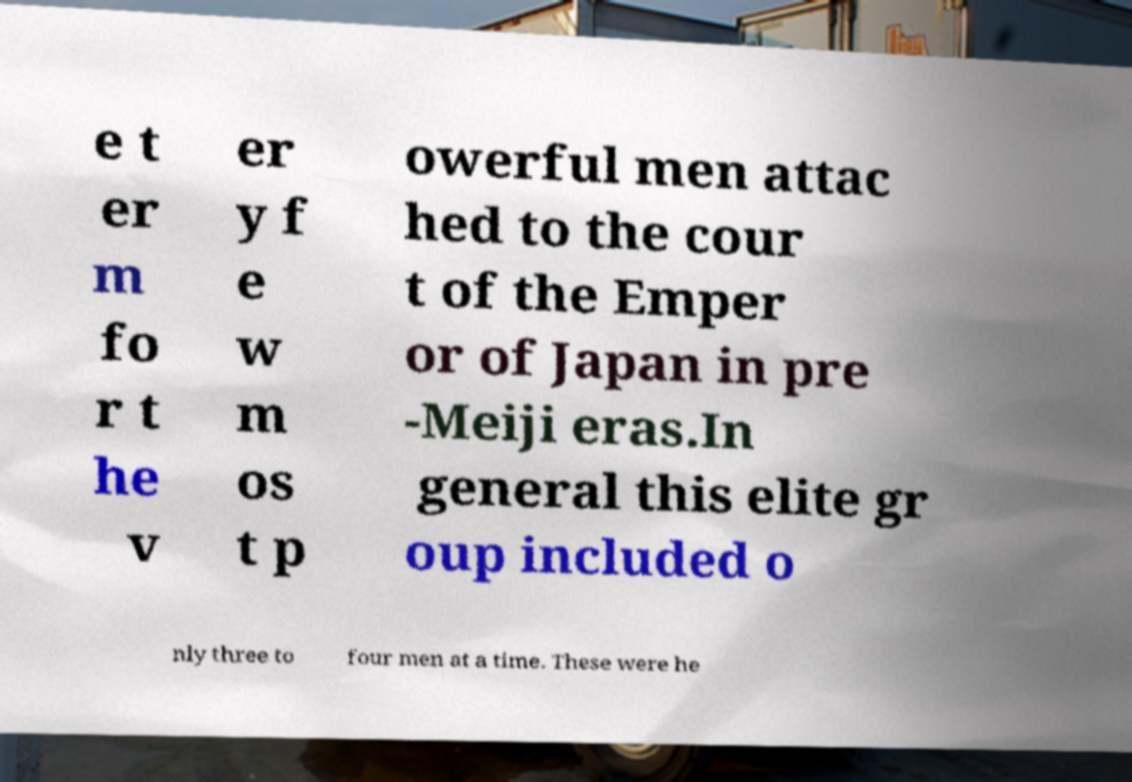Please identify and transcribe the text found in this image. e t er m fo r t he v er y f e w m os t p owerful men attac hed to the cour t of the Emper or of Japan in pre -Meiji eras.In general this elite gr oup included o nly three to four men at a time. These were he 